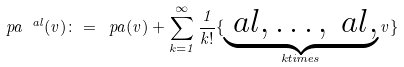Convert formula to latex. <formula><loc_0><loc_0><loc_500><loc_500>\ p a ^ { \ a l } ( v ) \colon = \ p a ( v ) + \sum _ { k = 1 } ^ { \infty } \frac { 1 } { k ! } \{ \underbrace { \ a l , \dots , \ a l , } _ { k t i m e s } v \}</formula> 